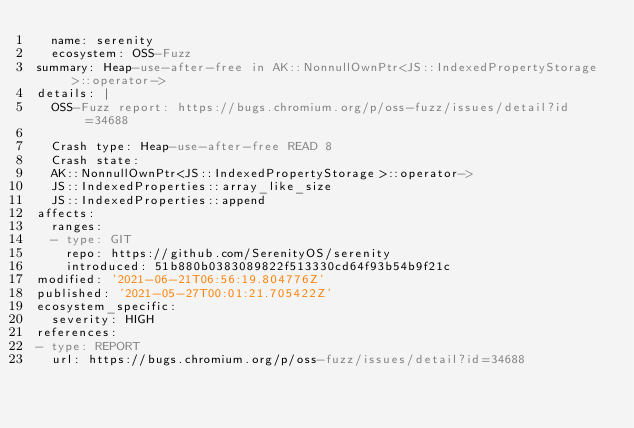Convert code to text. <code><loc_0><loc_0><loc_500><loc_500><_YAML_>  name: serenity
  ecosystem: OSS-Fuzz
summary: Heap-use-after-free in AK::NonnullOwnPtr<JS::IndexedPropertyStorage>::operator->
details: |
  OSS-Fuzz report: https://bugs.chromium.org/p/oss-fuzz/issues/detail?id=34688

  Crash type: Heap-use-after-free READ 8
  Crash state:
  AK::NonnullOwnPtr<JS::IndexedPropertyStorage>::operator->
  JS::IndexedProperties::array_like_size
  JS::IndexedProperties::append
affects:
  ranges:
  - type: GIT
    repo: https://github.com/SerenityOS/serenity
    introduced: 51b880b0383089822f513330cd64f93b54b9f21c
modified: '2021-06-21T06:56:19.804776Z'
published: '2021-05-27T00:01:21.705422Z'
ecosystem_specific:
  severity: HIGH
references:
- type: REPORT
  url: https://bugs.chromium.org/p/oss-fuzz/issues/detail?id=34688
</code> 